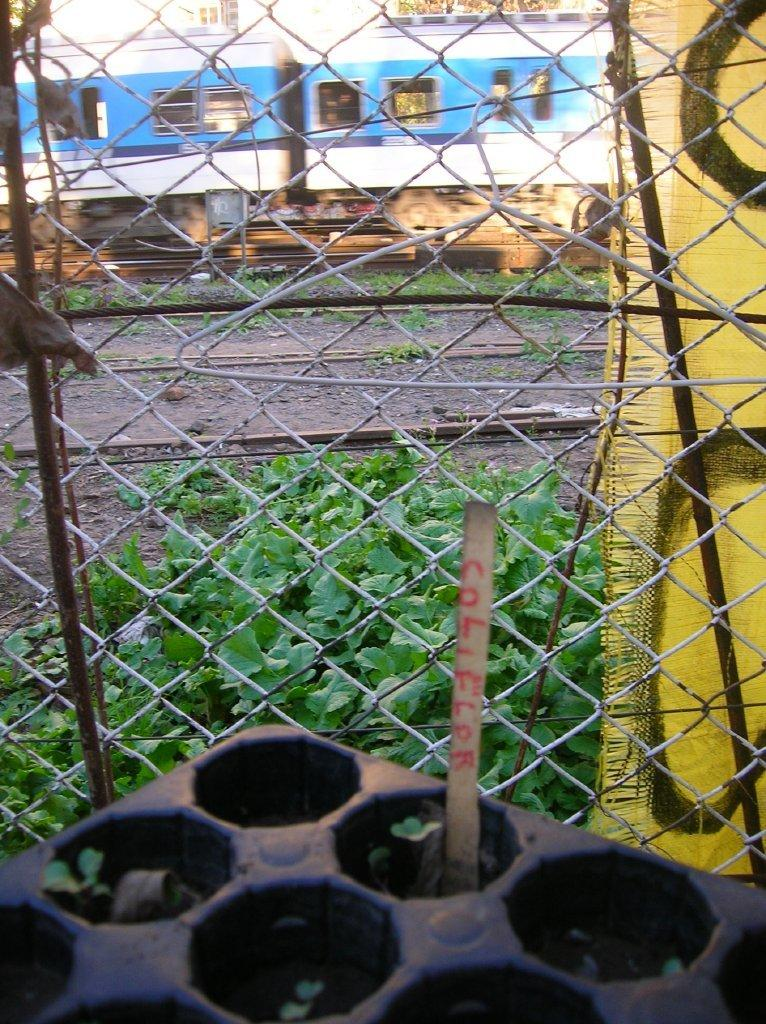What is the color and location of the object in the image? There is a black color object in the left corner of the image. What is in front of the black object? There is a fence in front of the black object. What can be seen in the background of the image? There is a train on the track in the background of the image. What type of polish is being applied to the bead in the image? There is no bead or polish present in the image; it features a black object, a fence, and a train in the background. Can you see a hose connected to the train in the image? There is no hose visible in the image; it only shows a train on the track in the background. 